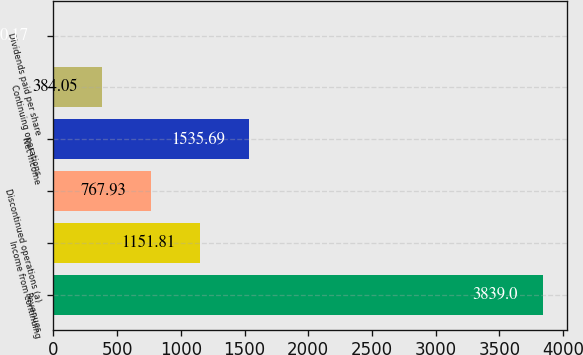Convert chart to OTSL. <chart><loc_0><loc_0><loc_500><loc_500><bar_chart><fcel>Revenues<fcel>Income from continuing<fcel>Discontinued operations (a)<fcel>Net income<fcel>Continuing operations<fcel>Dividends paid per share<nl><fcel>3839<fcel>1151.81<fcel>767.93<fcel>1535.69<fcel>384.05<fcel>0.17<nl></chart> 